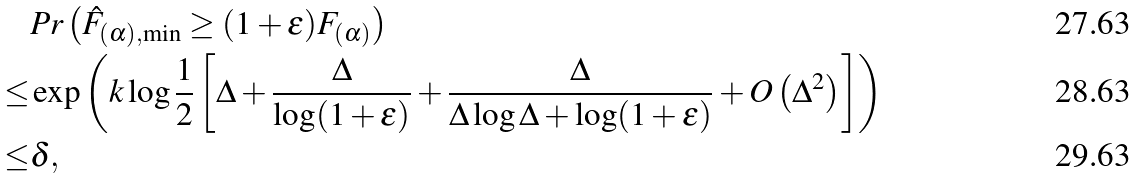Convert formula to latex. <formula><loc_0><loc_0><loc_500><loc_500>& P r \left ( \hat { F } _ { ( \alpha ) , \min } \geq ( 1 + \epsilon ) F _ { ( \alpha ) } \right ) \\ \leq & \exp \left ( k \log \frac { 1 } { 2 } \left [ \Delta + \frac { \Delta } { \log ( 1 + \epsilon ) } + \frac { \Delta } { \Delta \log \Delta + \log ( 1 + \epsilon ) } + O \left ( \Delta ^ { 2 } \right ) \right ] \right ) \\ \leq & \delta ,</formula> 